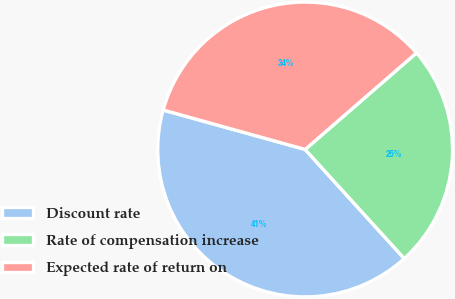Convert chart to OTSL. <chart><loc_0><loc_0><loc_500><loc_500><pie_chart><fcel>Discount rate<fcel>Rate of compensation increase<fcel>Expected rate of return on<nl><fcel>41.05%<fcel>24.63%<fcel>34.32%<nl></chart> 